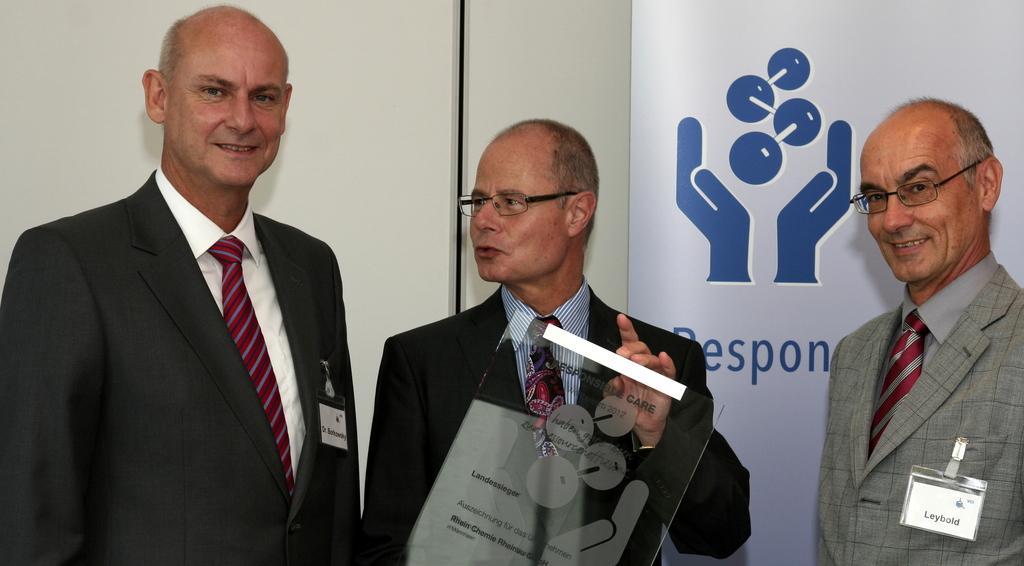How would you summarize this image in a sentence or two? In the image we can see three men are standing and the middle person is holding a glass board in his hand. In the background there is a wall and a hoarding. 